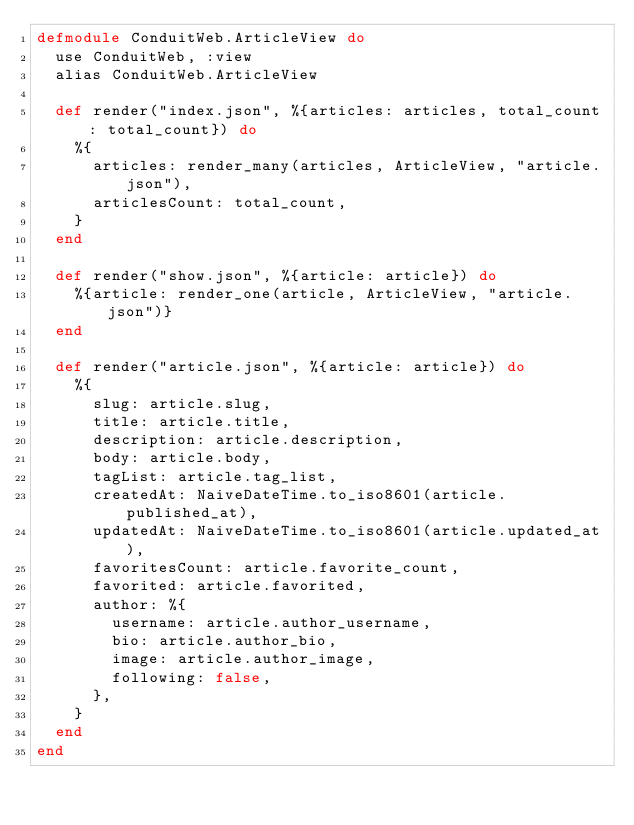Convert code to text. <code><loc_0><loc_0><loc_500><loc_500><_Elixir_>defmodule ConduitWeb.ArticleView do
  use ConduitWeb, :view
  alias ConduitWeb.ArticleView

  def render("index.json", %{articles: articles, total_count: total_count}) do
    %{
      articles: render_many(articles, ArticleView, "article.json"),
      articlesCount: total_count,
    }
  end

  def render("show.json", %{article: article}) do
    %{article: render_one(article, ArticleView, "article.json")}
  end

  def render("article.json", %{article: article}) do
    %{
      slug: article.slug,
      title: article.title,
      description: article.description,
      body: article.body,
      tagList: article.tag_list,
      createdAt: NaiveDateTime.to_iso8601(article.published_at),
      updatedAt: NaiveDateTime.to_iso8601(article.updated_at),
      favoritesCount: article.favorite_count,
      favorited: article.favorited,
      author: %{
        username: article.author_username,
        bio: article.author_bio,
        image: article.author_image,
        following: false,
      },
    }
  end
end
</code> 